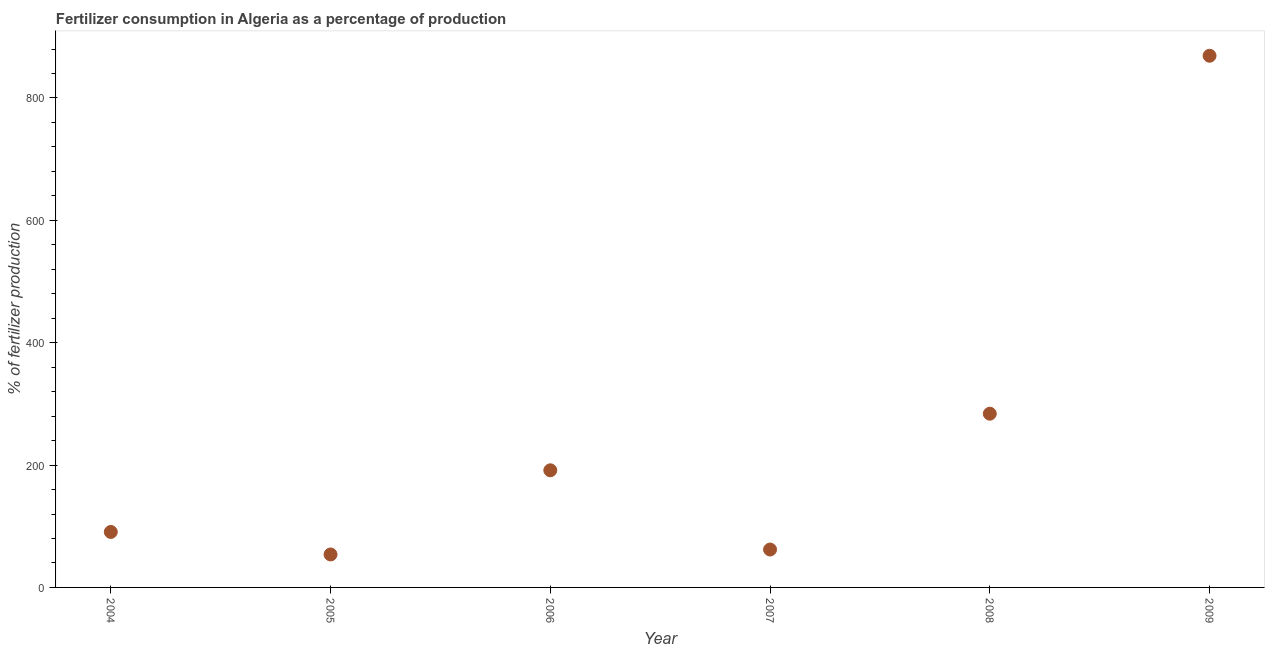What is the amount of fertilizer consumption in 2005?
Your response must be concise. 53.9. Across all years, what is the maximum amount of fertilizer consumption?
Ensure brevity in your answer.  869. Across all years, what is the minimum amount of fertilizer consumption?
Offer a very short reply. 53.9. In which year was the amount of fertilizer consumption minimum?
Your answer should be very brief. 2005. What is the sum of the amount of fertilizer consumption?
Your answer should be very brief. 1550.95. What is the difference between the amount of fertilizer consumption in 2005 and 2008?
Your response must be concise. -230.05. What is the average amount of fertilizer consumption per year?
Provide a short and direct response. 258.49. What is the median amount of fertilizer consumption?
Give a very brief answer. 141.07. What is the ratio of the amount of fertilizer consumption in 2004 to that in 2005?
Your answer should be very brief. 1.68. What is the difference between the highest and the second highest amount of fertilizer consumption?
Provide a succinct answer. 585.05. Is the sum of the amount of fertilizer consumption in 2005 and 2009 greater than the maximum amount of fertilizer consumption across all years?
Your answer should be compact. Yes. What is the difference between the highest and the lowest amount of fertilizer consumption?
Offer a very short reply. 815.1. How many dotlines are there?
Offer a very short reply. 1. How many years are there in the graph?
Your answer should be compact. 6. What is the difference between two consecutive major ticks on the Y-axis?
Offer a terse response. 200. Are the values on the major ticks of Y-axis written in scientific E-notation?
Make the answer very short. No. What is the title of the graph?
Give a very brief answer. Fertilizer consumption in Algeria as a percentage of production. What is the label or title of the Y-axis?
Your answer should be compact. % of fertilizer production. What is the % of fertilizer production in 2004?
Your answer should be compact. 90.69. What is the % of fertilizer production in 2005?
Make the answer very short. 53.9. What is the % of fertilizer production in 2006?
Your response must be concise. 191.44. What is the % of fertilizer production in 2007?
Your answer should be very brief. 61.95. What is the % of fertilizer production in 2008?
Your answer should be compact. 283.96. What is the % of fertilizer production in 2009?
Your answer should be very brief. 869. What is the difference between the % of fertilizer production in 2004 and 2005?
Make the answer very short. 36.79. What is the difference between the % of fertilizer production in 2004 and 2006?
Your response must be concise. -100.75. What is the difference between the % of fertilizer production in 2004 and 2007?
Give a very brief answer. 28.74. What is the difference between the % of fertilizer production in 2004 and 2008?
Provide a short and direct response. -193.27. What is the difference between the % of fertilizer production in 2004 and 2009?
Provide a succinct answer. -778.31. What is the difference between the % of fertilizer production in 2005 and 2006?
Your response must be concise. -137.54. What is the difference between the % of fertilizer production in 2005 and 2007?
Offer a terse response. -8.04. What is the difference between the % of fertilizer production in 2005 and 2008?
Your response must be concise. -230.05. What is the difference between the % of fertilizer production in 2005 and 2009?
Provide a succinct answer. -815.1. What is the difference between the % of fertilizer production in 2006 and 2007?
Offer a terse response. 129.5. What is the difference between the % of fertilizer production in 2006 and 2008?
Provide a succinct answer. -92.51. What is the difference between the % of fertilizer production in 2006 and 2009?
Ensure brevity in your answer.  -677.56. What is the difference between the % of fertilizer production in 2007 and 2008?
Provide a short and direct response. -222.01. What is the difference between the % of fertilizer production in 2007 and 2009?
Your response must be concise. -807.06. What is the difference between the % of fertilizer production in 2008 and 2009?
Make the answer very short. -585.05. What is the ratio of the % of fertilizer production in 2004 to that in 2005?
Offer a terse response. 1.68. What is the ratio of the % of fertilizer production in 2004 to that in 2006?
Provide a succinct answer. 0.47. What is the ratio of the % of fertilizer production in 2004 to that in 2007?
Your response must be concise. 1.46. What is the ratio of the % of fertilizer production in 2004 to that in 2008?
Give a very brief answer. 0.32. What is the ratio of the % of fertilizer production in 2004 to that in 2009?
Your answer should be very brief. 0.1. What is the ratio of the % of fertilizer production in 2005 to that in 2006?
Give a very brief answer. 0.28. What is the ratio of the % of fertilizer production in 2005 to that in 2007?
Make the answer very short. 0.87. What is the ratio of the % of fertilizer production in 2005 to that in 2008?
Offer a very short reply. 0.19. What is the ratio of the % of fertilizer production in 2005 to that in 2009?
Provide a short and direct response. 0.06. What is the ratio of the % of fertilizer production in 2006 to that in 2007?
Keep it short and to the point. 3.09. What is the ratio of the % of fertilizer production in 2006 to that in 2008?
Ensure brevity in your answer.  0.67. What is the ratio of the % of fertilizer production in 2006 to that in 2009?
Offer a very short reply. 0.22. What is the ratio of the % of fertilizer production in 2007 to that in 2008?
Keep it short and to the point. 0.22. What is the ratio of the % of fertilizer production in 2007 to that in 2009?
Offer a very short reply. 0.07. What is the ratio of the % of fertilizer production in 2008 to that in 2009?
Your response must be concise. 0.33. 